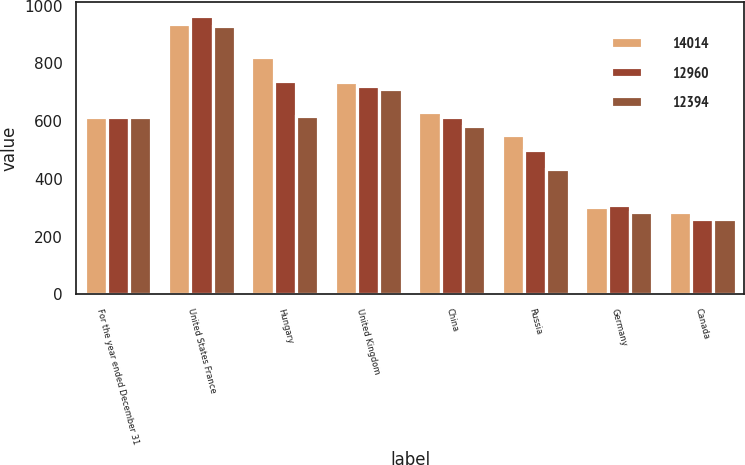<chart> <loc_0><loc_0><loc_500><loc_500><stacked_bar_chart><ecel><fcel>For the year ended December 31<fcel>United States France<fcel>Hungary<fcel>United Kingdom<fcel>China<fcel>Russia<fcel>Germany<fcel>Canada<nl><fcel>14014<fcel>615<fcel>936<fcel>823<fcel>737<fcel>632<fcel>553<fcel>302<fcel>285<nl><fcel>12960<fcel>615<fcel>965<fcel>739<fcel>721<fcel>615<fcel>500<fcel>309<fcel>261<nl><fcel>12394<fcel>615<fcel>930<fcel>619<fcel>711<fcel>582<fcel>433<fcel>284<fcel>262<nl></chart> 